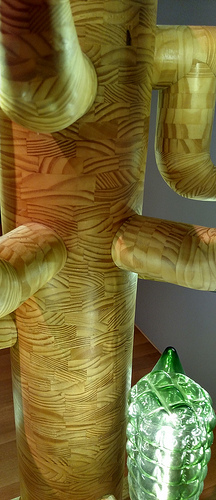<image>
Is the pattern on the wall? No. The pattern is not positioned on the wall. They may be near each other, but the pattern is not supported by or resting on top of the wall. 